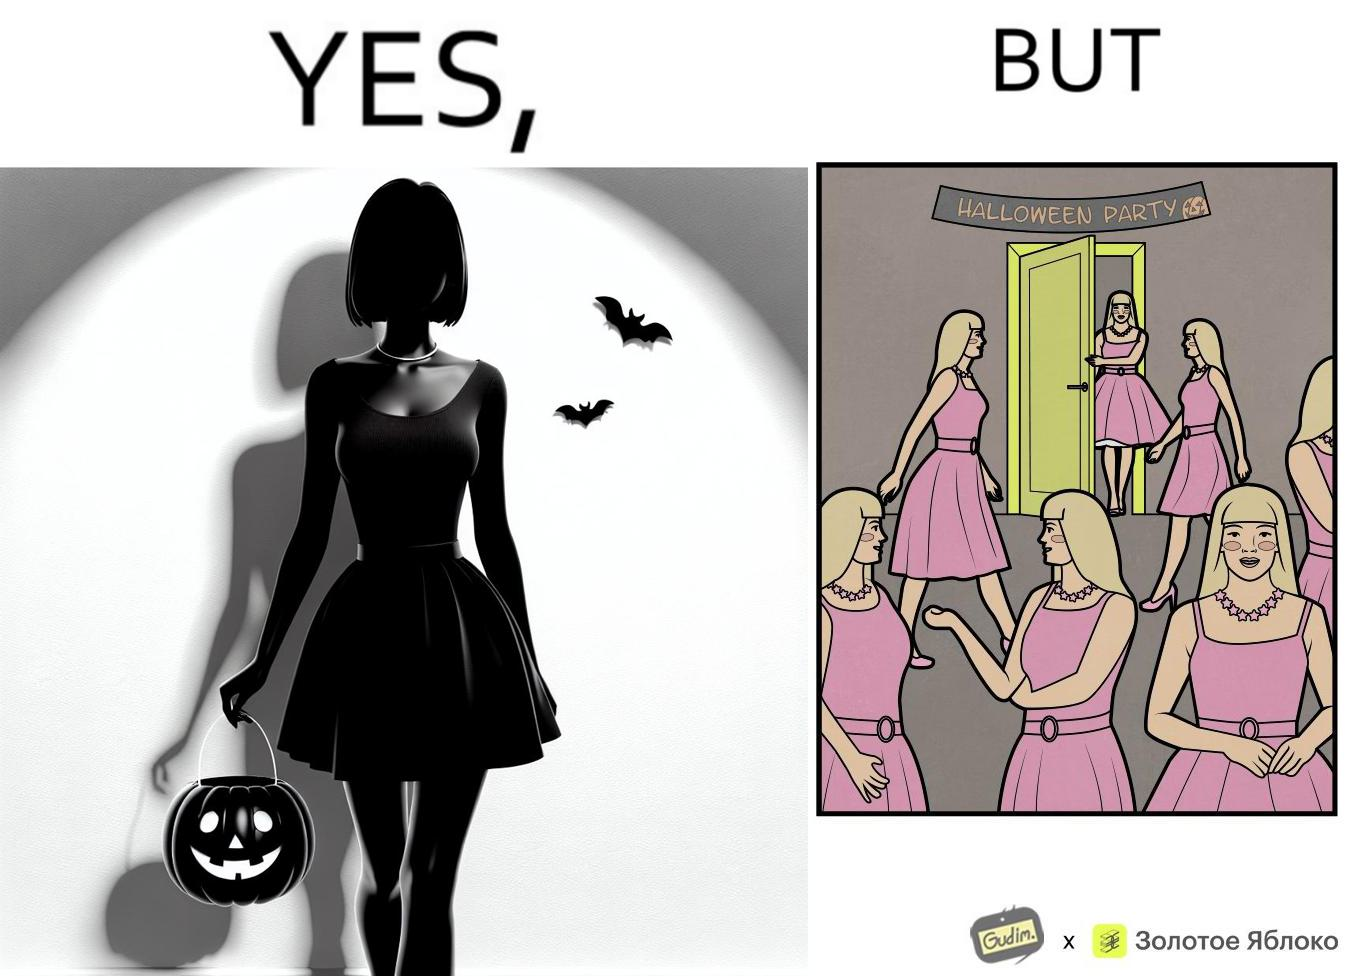Provide a description of this image. The image is funny, as the person entering the Halloween Party has a costume that is identical to many other people in the party. 